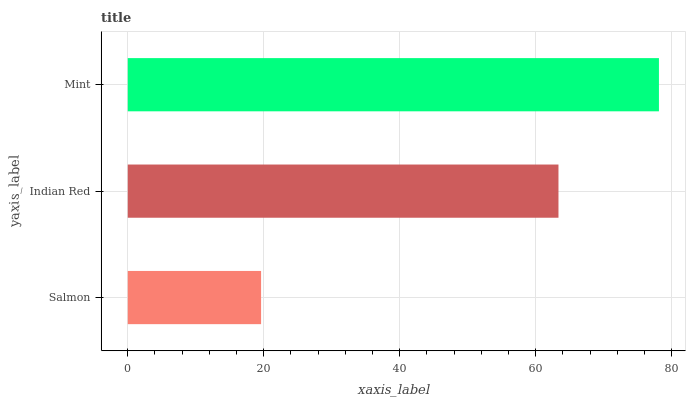Is Salmon the minimum?
Answer yes or no. Yes. Is Mint the maximum?
Answer yes or no. Yes. Is Indian Red the minimum?
Answer yes or no. No. Is Indian Red the maximum?
Answer yes or no. No. Is Indian Red greater than Salmon?
Answer yes or no. Yes. Is Salmon less than Indian Red?
Answer yes or no. Yes. Is Salmon greater than Indian Red?
Answer yes or no. No. Is Indian Red less than Salmon?
Answer yes or no. No. Is Indian Red the high median?
Answer yes or no. Yes. Is Indian Red the low median?
Answer yes or no. Yes. Is Salmon the high median?
Answer yes or no. No. Is Salmon the low median?
Answer yes or no. No. 